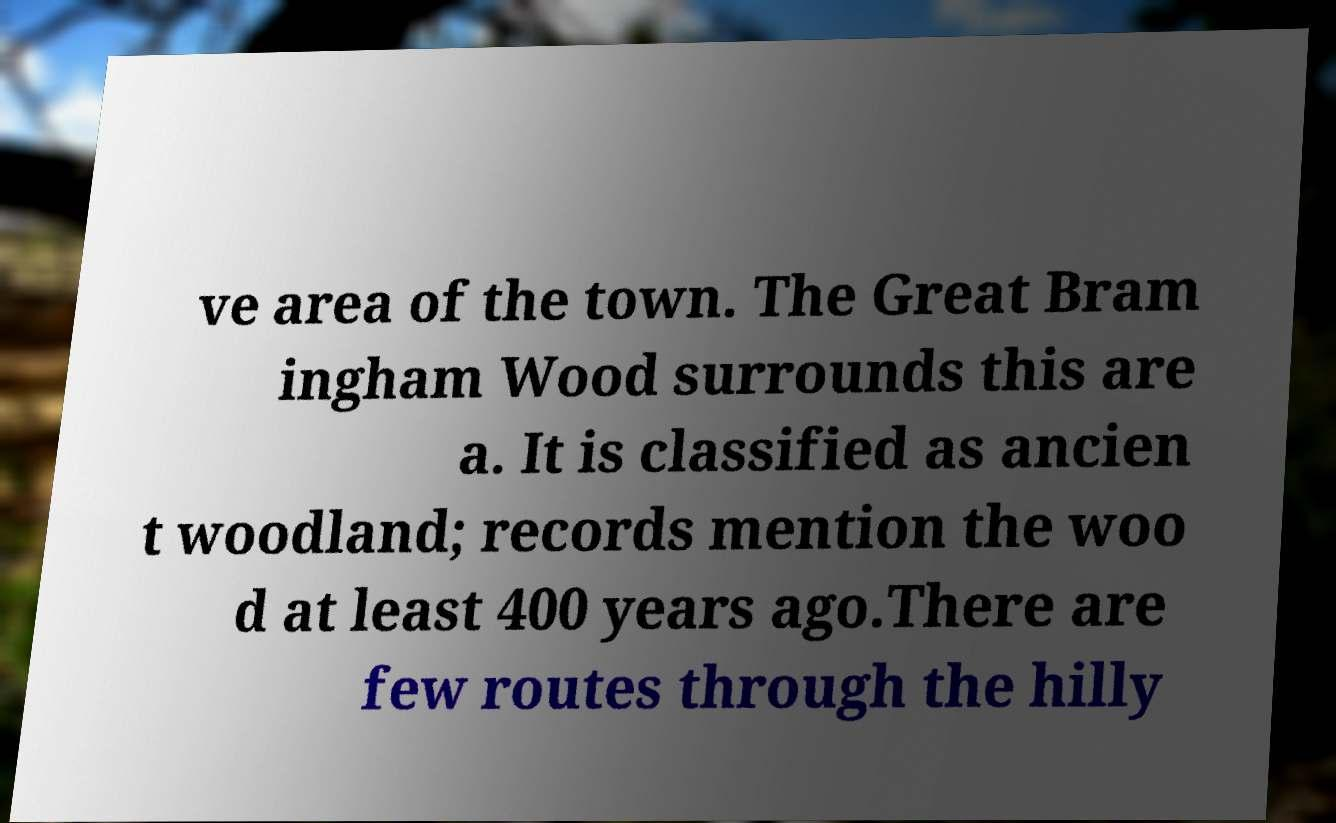For documentation purposes, I need the text within this image transcribed. Could you provide that? ve area of the town. The Great Bram ingham Wood surrounds this are a. It is classified as ancien t woodland; records mention the woo d at least 400 years ago.There are few routes through the hilly 